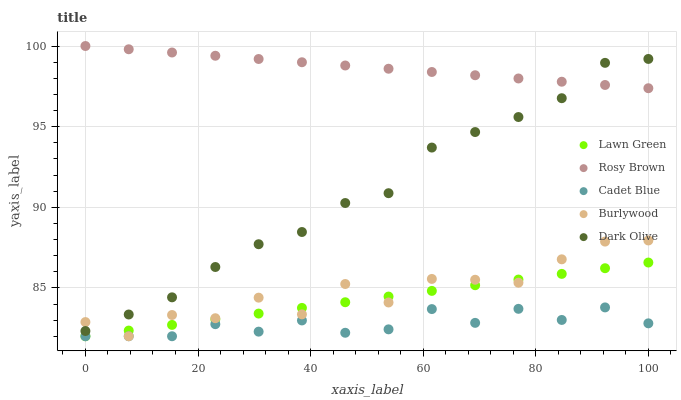Does Cadet Blue have the minimum area under the curve?
Answer yes or no. Yes. Does Rosy Brown have the maximum area under the curve?
Answer yes or no. Yes. Does Lawn Green have the minimum area under the curve?
Answer yes or no. No. Does Lawn Green have the maximum area under the curve?
Answer yes or no. No. Is Lawn Green the smoothest?
Answer yes or no. Yes. Is Burlywood the roughest?
Answer yes or no. Yes. Is Rosy Brown the smoothest?
Answer yes or no. No. Is Rosy Brown the roughest?
Answer yes or no. No. Does Cadet Blue have the lowest value?
Answer yes or no. Yes. Does Rosy Brown have the lowest value?
Answer yes or no. No. Does Rosy Brown have the highest value?
Answer yes or no. Yes. Does Lawn Green have the highest value?
Answer yes or no. No. Is Lawn Green less than Dark Olive?
Answer yes or no. Yes. Is Dark Olive greater than Lawn Green?
Answer yes or no. Yes. Does Cadet Blue intersect Lawn Green?
Answer yes or no. Yes. Is Cadet Blue less than Lawn Green?
Answer yes or no. No. Is Cadet Blue greater than Lawn Green?
Answer yes or no. No. Does Lawn Green intersect Dark Olive?
Answer yes or no. No. 